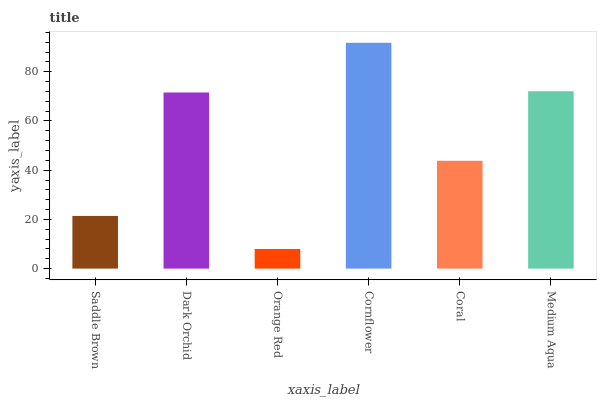Is Dark Orchid the minimum?
Answer yes or no. No. Is Dark Orchid the maximum?
Answer yes or no. No. Is Dark Orchid greater than Saddle Brown?
Answer yes or no. Yes. Is Saddle Brown less than Dark Orchid?
Answer yes or no. Yes. Is Saddle Brown greater than Dark Orchid?
Answer yes or no. No. Is Dark Orchid less than Saddle Brown?
Answer yes or no. No. Is Dark Orchid the high median?
Answer yes or no. Yes. Is Coral the low median?
Answer yes or no. Yes. Is Saddle Brown the high median?
Answer yes or no. No. Is Dark Orchid the low median?
Answer yes or no. No. 